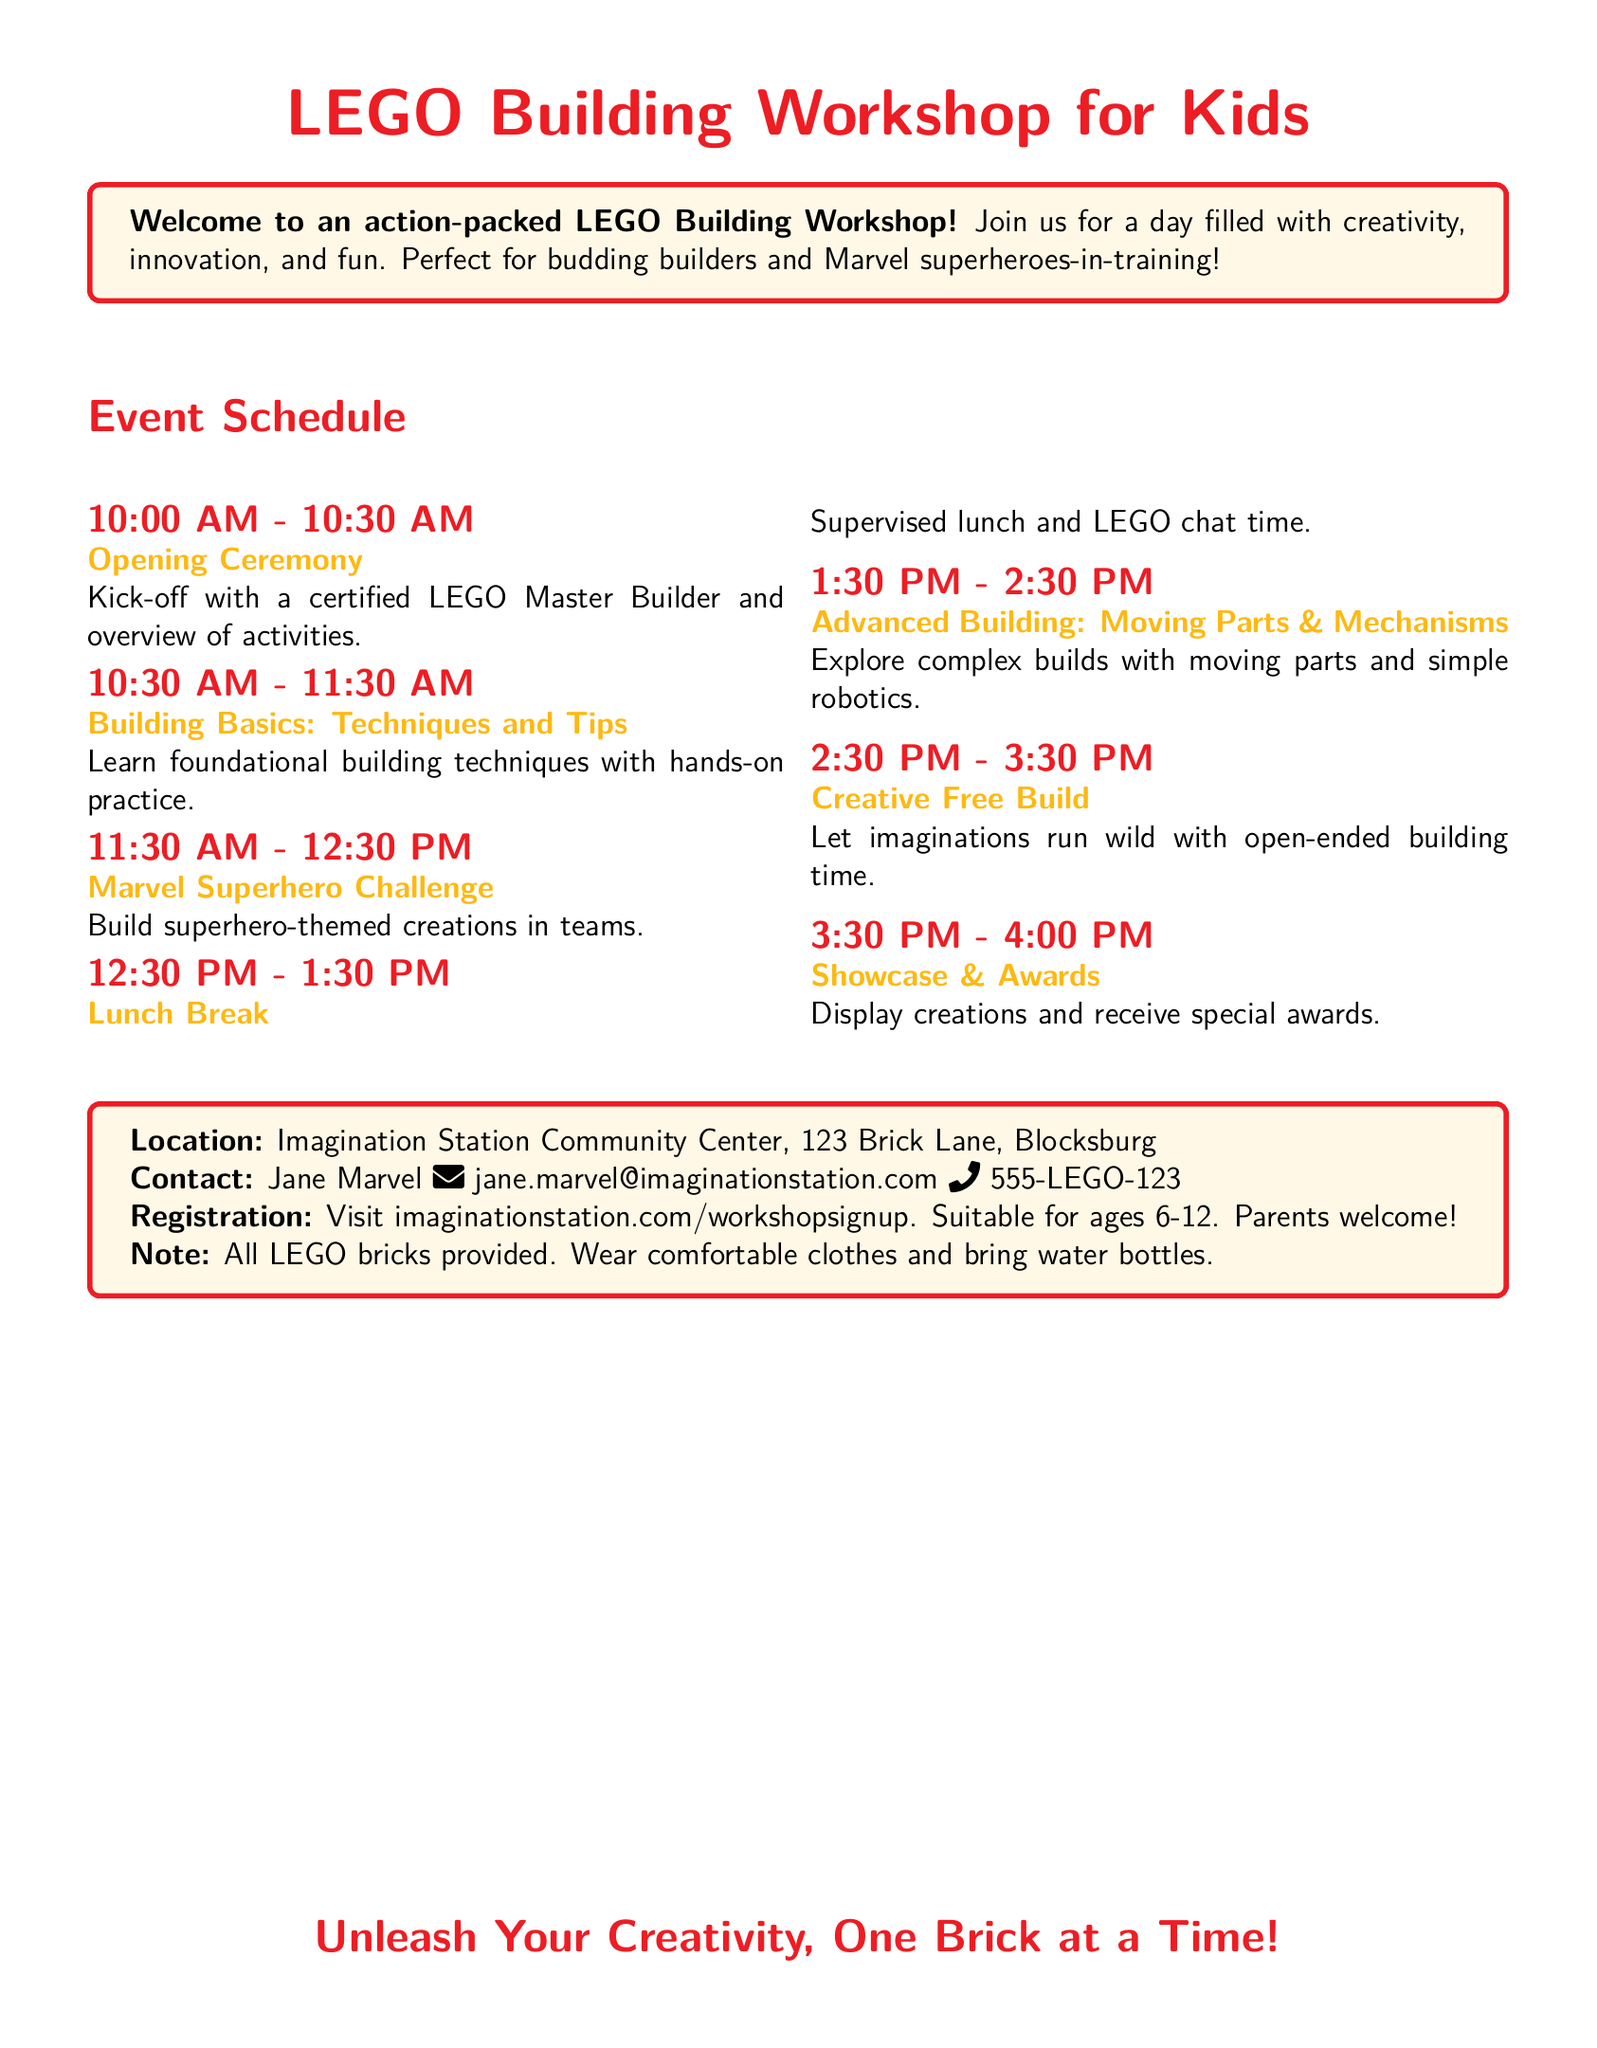What is the location of the workshop? The document specifies the location as Imagination Station Community Center, 123 Brick Lane, Blocksburg.
Answer: Imagination Station Community Center, 123 Brick Lane, Blocksburg Who can be contacted for more information? The document lists Jane Marvel as the contact person for inquiries about the workshop.
Answer: Jane Marvel What time does the Opening Ceremony start? The schedule states that the Opening Ceremony starts at 10:00 AM.
Answer: 10:00 AM How long is the lunch break? According to the schedule, the lunch break lasts for one hour.
Answer: 1 hour What is one of the themes for the building challenges? The document mentions the Marvel Superhero Challenge as a themed building activity.
Answer: Marvel Superhero Challenge How many awards will be given out during the showcase? The document does not specify the number of awards but indicates there will be awards given during the showcase.
Answer: Special awards What age range is suitable for this workshop? The document notes that the workshop is suitable for children aged 6 to 12 years old.
Answer: 6-12 What item should participants bring with them? The document advises participants to bring water bottles for the workshop.
Answer: Water bottles 